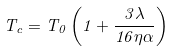<formula> <loc_0><loc_0><loc_500><loc_500>T _ { c } = T _ { 0 } \left ( 1 + \frac { 3 \lambda } { 1 6 \eta \alpha } \right )</formula> 